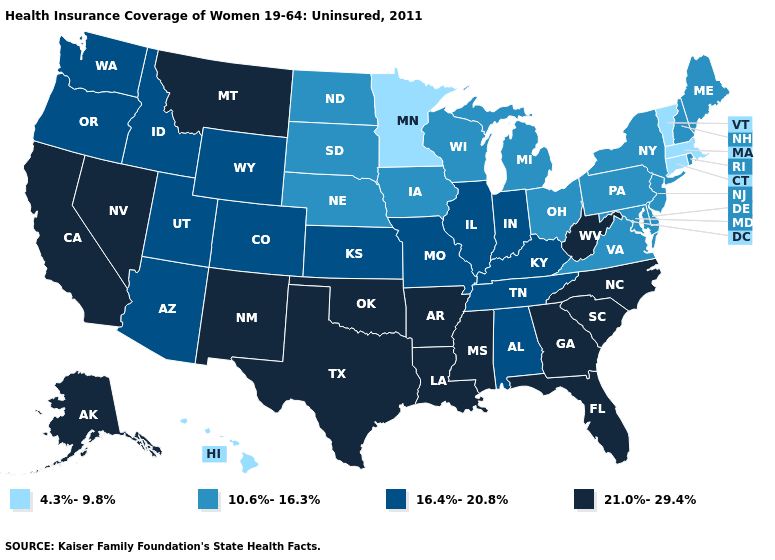Does Kansas have a lower value than Florida?
Concise answer only. Yes. What is the value of Florida?
Give a very brief answer. 21.0%-29.4%. Name the states that have a value in the range 10.6%-16.3%?
Write a very short answer. Delaware, Iowa, Maine, Maryland, Michigan, Nebraska, New Hampshire, New Jersey, New York, North Dakota, Ohio, Pennsylvania, Rhode Island, South Dakota, Virginia, Wisconsin. What is the lowest value in states that border Maine?
Concise answer only. 10.6%-16.3%. Which states have the lowest value in the USA?
Keep it brief. Connecticut, Hawaii, Massachusetts, Minnesota, Vermont. Does the map have missing data?
Keep it brief. No. What is the value of New Jersey?
Give a very brief answer. 10.6%-16.3%. What is the highest value in the South ?
Concise answer only. 21.0%-29.4%. What is the value of New Hampshire?
Short answer required. 10.6%-16.3%. What is the value of Virginia?
Quick response, please. 10.6%-16.3%. How many symbols are there in the legend?
Write a very short answer. 4. Does New Mexico have the highest value in the West?
Give a very brief answer. Yes. What is the lowest value in the USA?
Concise answer only. 4.3%-9.8%. What is the value of Utah?
Concise answer only. 16.4%-20.8%. Does the map have missing data?
Give a very brief answer. No. 